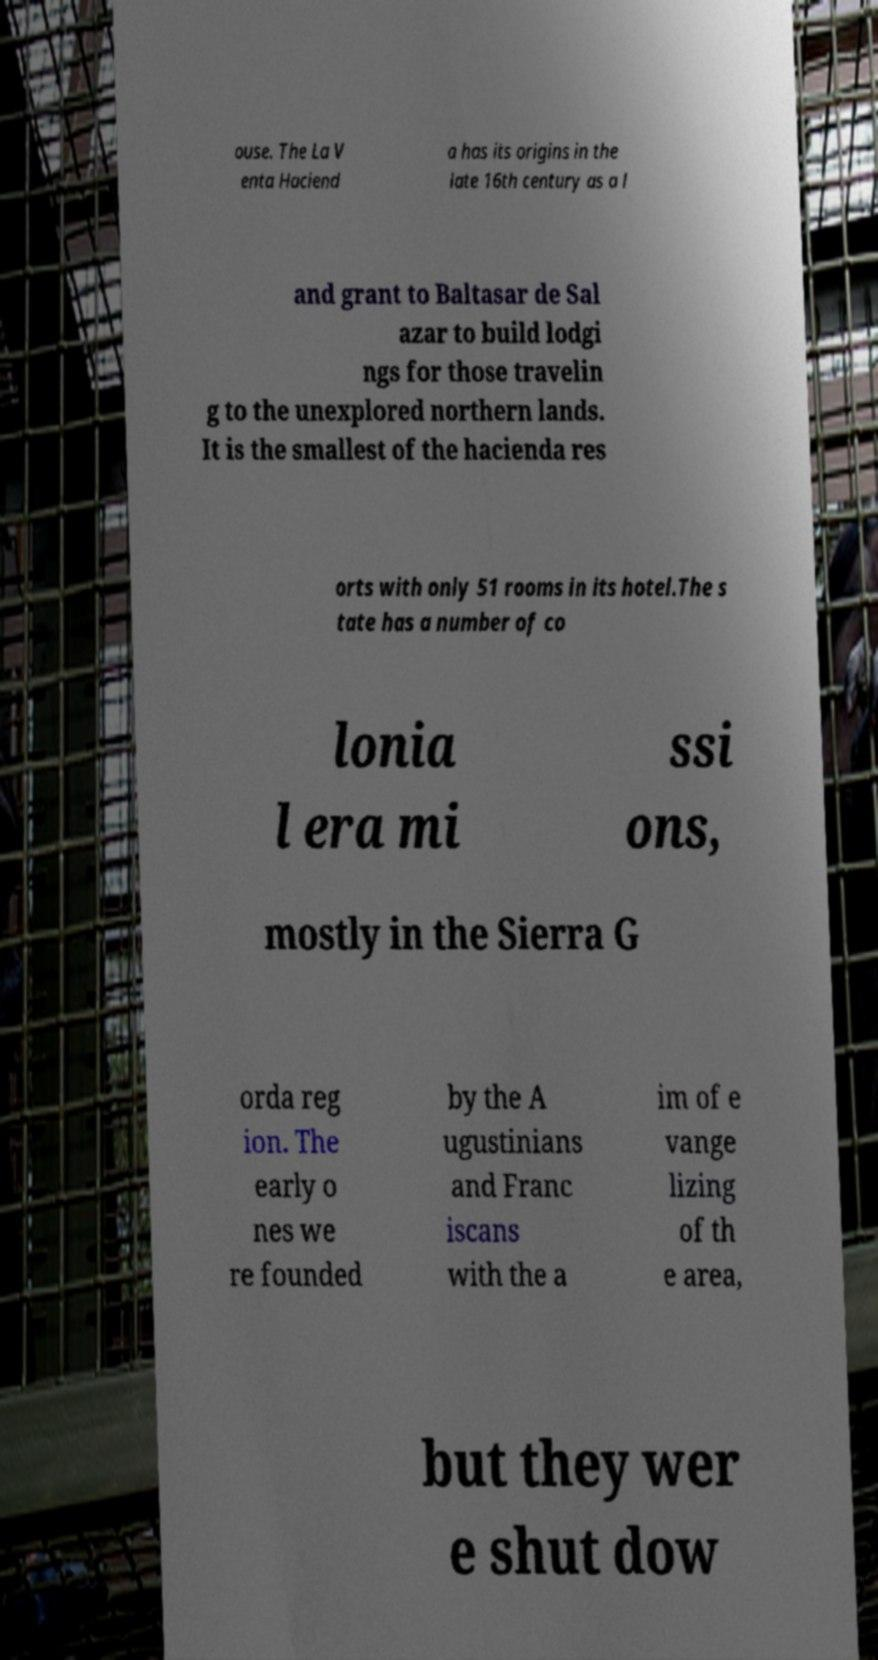There's text embedded in this image that I need extracted. Can you transcribe it verbatim? ouse. The La V enta Haciend a has its origins in the late 16th century as a l and grant to Baltasar de Sal azar to build lodgi ngs for those travelin g to the unexplored northern lands. It is the smallest of the hacienda res orts with only 51 rooms in its hotel.The s tate has a number of co lonia l era mi ssi ons, mostly in the Sierra G orda reg ion. The early o nes we re founded by the A ugustinians and Franc iscans with the a im of e vange lizing of th e area, but they wer e shut dow 